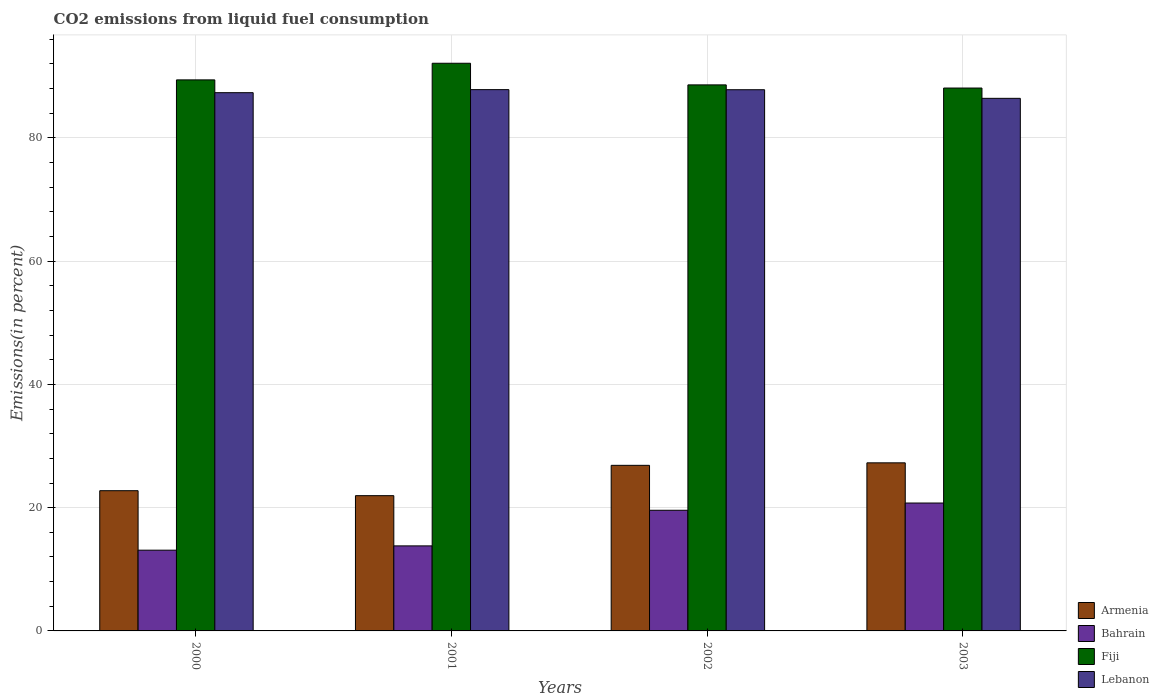How many different coloured bars are there?
Your answer should be compact. 4. Are the number of bars on each tick of the X-axis equal?
Ensure brevity in your answer.  Yes. How many bars are there on the 1st tick from the right?
Offer a very short reply. 4. What is the label of the 4th group of bars from the left?
Provide a short and direct response. 2003. What is the total CO2 emitted in Armenia in 2002?
Your response must be concise. 26.87. Across all years, what is the maximum total CO2 emitted in Fiji?
Your answer should be very brief. 92.11. Across all years, what is the minimum total CO2 emitted in Bahrain?
Offer a terse response. 13.1. What is the total total CO2 emitted in Armenia in the graph?
Offer a terse response. 98.84. What is the difference between the total CO2 emitted in Fiji in 2001 and that in 2003?
Offer a very short reply. 4.02. What is the difference between the total CO2 emitted in Lebanon in 2000 and the total CO2 emitted in Armenia in 2003?
Give a very brief answer. 60.06. What is the average total CO2 emitted in Armenia per year?
Your answer should be very brief. 24.71. In the year 2001, what is the difference between the total CO2 emitted in Bahrain and total CO2 emitted in Lebanon?
Provide a succinct answer. -74.03. What is the ratio of the total CO2 emitted in Bahrain in 2001 to that in 2003?
Your response must be concise. 0.66. Is the total CO2 emitted in Bahrain in 2002 less than that in 2003?
Keep it short and to the point. Yes. What is the difference between the highest and the second highest total CO2 emitted in Armenia?
Give a very brief answer. 0.41. What is the difference between the highest and the lowest total CO2 emitted in Lebanon?
Keep it short and to the point. 1.41. In how many years, is the total CO2 emitted in Armenia greater than the average total CO2 emitted in Armenia taken over all years?
Your answer should be very brief. 2. Is the sum of the total CO2 emitted in Lebanon in 2001 and 2002 greater than the maximum total CO2 emitted in Armenia across all years?
Provide a succinct answer. Yes. Is it the case that in every year, the sum of the total CO2 emitted in Armenia and total CO2 emitted in Lebanon is greater than the sum of total CO2 emitted in Bahrain and total CO2 emitted in Fiji?
Provide a short and direct response. No. What does the 3rd bar from the left in 2002 represents?
Give a very brief answer. Fiji. What does the 3rd bar from the right in 2002 represents?
Provide a short and direct response. Bahrain. How many bars are there?
Keep it short and to the point. 16. Are all the bars in the graph horizontal?
Ensure brevity in your answer.  No. How many years are there in the graph?
Your response must be concise. 4. Are the values on the major ticks of Y-axis written in scientific E-notation?
Your answer should be compact. No. How many legend labels are there?
Give a very brief answer. 4. How are the legend labels stacked?
Ensure brevity in your answer.  Vertical. What is the title of the graph?
Your response must be concise. CO2 emissions from liquid fuel consumption. Does "Malta" appear as one of the legend labels in the graph?
Provide a short and direct response. No. What is the label or title of the X-axis?
Offer a terse response. Years. What is the label or title of the Y-axis?
Provide a short and direct response. Emissions(in percent). What is the Emissions(in percent) in Armenia in 2000?
Keep it short and to the point. 22.75. What is the Emissions(in percent) of Bahrain in 2000?
Keep it short and to the point. 13.1. What is the Emissions(in percent) in Fiji in 2000?
Make the answer very short. 89.41. What is the Emissions(in percent) in Lebanon in 2000?
Your answer should be very brief. 87.33. What is the Emissions(in percent) in Armenia in 2001?
Your response must be concise. 21.95. What is the Emissions(in percent) of Bahrain in 2001?
Provide a succinct answer. 13.8. What is the Emissions(in percent) of Fiji in 2001?
Your answer should be very brief. 92.11. What is the Emissions(in percent) of Lebanon in 2001?
Your answer should be compact. 87.83. What is the Emissions(in percent) in Armenia in 2002?
Provide a short and direct response. 26.87. What is the Emissions(in percent) in Bahrain in 2002?
Your answer should be compact. 19.57. What is the Emissions(in percent) in Fiji in 2002?
Your answer should be compact. 88.6. What is the Emissions(in percent) of Lebanon in 2002?
Offer a terse response. 87.81. What is the Emissions(in percent) of Armenia in 2003?
Your response must be concise. 27.27. What is the Emissions(in percent) of Bahrain in 2003?
Ensure brevity in your answer.  20.75. What is the Emissions(in percent) of Fiji in 2003?
Give a very brief answer. 88.09. What is the Emissions(in percent) of Lebanon in 2003?
Keep it short and to the point. 86.41. Across all years, what is the maximum Emissions(in percent) of Armenia?
Keep it short and to the point. 27.27. Across all years, what is the maximum Emissions(in percent) of Bahrain?
Your response must be concise. 20.75. Across all years, what is the maximum Emissions(in percent) of Fiji?
Your response must be concise. 92.11. Across all years, what is the maximum Emissions(in percent) of Lebanon?
Your answer should be very brief. 87.83. Across all years, what is the minimum Emissions(in percent) of Armenia?
Your response must be concise. 21.95. Across all years, what is the minimum Emissions(in percent) of Bahrain?
Give a very brief answer. 13.1. Across all years, what is the minimum Emissions(in percent) in Fiji?
Make the answer very short. 88.09. Across all years, what is the minimum Emissions(in percent) in Lebanon?
Offer a terse response. 86.41. What is the total Emissions(in percent) of Armenia in the graph?
Your response must be concise. 98.84. What is the total Emissions(in percent) of Bahrain in the graph?
Your response must be concise. 67.22. What is the total Emissions(in percent) of Fiji in the graph?
Offer a very short reply. 358.19. What is the total Emissions(in percent) in Lebanon in the graph?
Your answer should be compact. 349.38. What is the difference between the Emissions(in percent) in Armenia in 2000 and that in 2001?
Your answer should be compact. 0.81. What is the difference between the Emissions(in percent) of Bahrain in 2000 and that in 2001?
Make the answer very short. -0.7. What is the difference between the Emissions(in percent) in Fiji in 2000 and that in 2001?
Give a very brief answer. -2.7. What is the difference between the Emissions(in percent) in Lebanon in 2000 and that in 2001?
Provide a succinct answer. -0.49. What is the difference between the Emissions(in percent) in Armenia in 2000 and that in 2002?
Offer a very short reply. -4.12. What is the difference between the Emissions(in percent) in Bahrain in 2000 and that in 2002?
Keep it short and to the point. -6.47. What is the difference between the Emissions(in percent) in Fiji in 2000 and that in 2002?
Offer a very short reply. 0.81. What is the difference between the Emissions(in percent) of Lebanon in 2000 and that in 2002?
Make the answer very short. -0.48. What is the difference between the Emissions(in percent) of Armenia in 2000 and that in 2003?
Keep it short and to the point. -4.52. What is the difference between the Emissions(in percent) in Bahrain in 2000 and that in 2003?
Give a very brief answer. -7.65. What is the difference between the Emissions(in percent) in Fiji in 2000 and that in 2003?
Your answer should be very brief. 1.32. What is the difference between the Emissions(in percent) of Lebanon in 2000 and that in 2003?
Make the answer very short. 0.92. What is the difference between the Emissions(in percent) of Armenia in 2001 and that in 2002?
Give a very brief answer. -4.92. What is the difference between the Emissions(in percent) of Bahrain in 2001 and that in 2002?
Your answer should be very brief. -5.78. What is the difference between the Emissions(in percent) of Fiji in 2001 and that in 2002?
Keep it short and to the point. 3.51. What is the difference between the Emissions(in percent) in Lebanon in 2001 and that in 2002?
Give a very brief answer. 0.01. What is the difference between the Emissions(in percent) of Armenia in 2001 and that in 2003?
Provide a short and direct response. -5.33. What is the difference between the Emissions(in percent) in Bahrain in 2001 and that in 2003?
Make the answer very short. -6.96. What is the difference between the Emissions(in percent) in Fiji in 2001 and that in 2003?
Your answer should be compact. 4.02. What is the difference between the Emissions(in percent) of Lebanon in 2001 and that in 2003?
Offer a terse response. 1.41. What is the difference between the Emissions(in percent) of Armenia in 2002 and that in 2003?
Keep it short and to the point. -0.41. What is the difference between the Emissions(in percent) in Bahrain in 2002 and that in 2003?
Ensure brevity in your answer.  -1.18. What is the difference between the Emissions(in percent) of Fiji in 2002 and that in 2003?
Ensure brevity in your answer.  0.51. What is the difference between the Emissions(in percent) of Lebanon in 2002 and that in 2003?
Make the answer very short. 1.4. What is the difference between the Emissions(in percent) of Armenia in 2000 and the Emissions(in percent) of Bahrain in 2001?
Ensure brevity in your answer.  8.95. What is the difference between the Emissions(in percent) in Armenia in 2000 and the Emissions(in percent) in Fiji in 2001?
Keep it short and to the point. -69.35. What is the difference between the Emissions(in percent) of Armenia in 2000 and the Emissions(in percent) of Lebanon in 2001?
Provide a succinct answer. -65.07. What is the difference between the Emissions(in percent) in Bahrain in 2000 and the Emissions(in percent) in Fiji in 2001?
Provide a succinct answer. -79.01. What is the difference between the Emissions(in percent) of Bahrain in 2000 and the Emissions(in percent) of Lebanon in 2001?
Give a very brief answer. -74.73. What is the difference between the Emissions(in percent) in Fiji in 2000 and the Emissions(in percent) in Lebanon in 2001?
Your response must be concise. 1.58. What is the difference between the Emissions(in percent) of Armenia in 2000 and the Emissions(in percent) of Bahrain in 2002?
Provide a succinct answer. 3.18. What is the difference between the Emissions(in percent) of Armenia in 2000 and the Emissions(in percent) of Fiji in 2002?
Ensure brevity in your answer.  -65.85. What is the difference between the Emissions(in percent) in Armenia in 2000 and the Emissions(in percent) in Lebanon in 2002?
Your response must be concise. -65.06. What is the difference between the Emissions(in percent) of Bahrain in 2000 and the Emissions(in percent) of Fiji in 2002?
Ensure brevity in your answer.  -75.5. What is the difference between the Emissions(in percent) of Bahrain in 2000 and the Emissions(in percent) of Lebanon in 2002?
Give a very brief answer. -74.71. What is the difference between the Emissions(in percent) in Fiji in 2000 and the Emissions(in percent) in Lebanon in 2002?
Make the answer very short. 1.6. What is the difference between the Emissions(in percent) in Armenia in 2000 and the Emissions(in percent) in Bahrain in 2003?
Ensure brevity in your answer.  2. What is the difference between the Emissions(in percent) of Armenia in 2000 and the Emissions(in percent) of Fiji in 2003?
Your answer should be very brief. -65.33. What is the difference between the Emissions(in percent) of Armenia in 2000 and the Emissions(in percent) of Lebanon in 2003?
Provide a short and direct response. -63.66. What is the difference between the Emissions(in percent) in Bahrain in 2000 and the Emissions(in percent) in Fiji in 2003?
Provide a succinct answer. -74.99. What is the difference between the Emissions(in percent) of Bahrain in 2000 and the Emissions(in percent) of Lebanon in 2003?
Make the answer very short. -73.31. What is the difference between the Emissions(in percent) of Fiji in 2000 and the Emissions(in percent) of Lebanon in 2003?
Make the answer very short. 2.99. What is the difference between the Emissions(in percent) of Armenia in 2001 and the Emissions(in percent) of Bahrain in 2002?
Give a very brief answer. 2.37. What is the difference between the Emissions(in percent) of Armenia in 2001 and the Emissions(in percent) of Fiji in 2002?
Provide a short and direct response. -66.65. What is the difference between the Emissions(in percent) in Armenia in 2001 and the Emissions(in percent) in Lebanon in 2002?
Provide a succinct answer. -65.87. What is the difference between the Emissions(in percent) in Bahrain in 2001 and the Emissions(in percent) in Fiji in 2002?
Offer a terse response. -74.8. What is the difference between the Emissions(in percent) in Bahrain in 2001 and the Emissions(in percent) in Lebanon in 2002?
Give a very brief answer. -74.01. What is the difference between the Emissions(in percent) of Fiji in 2001 and the Emissions(in percent) of Lebanon in 2002?
Your answer should be very brief. 4.29. What is the difference between the Emissions(in percent) in Armenia in 2001 and the Emissions(in percent) in Bahrain in 2003?
Offer a very short reply. 1.19. What is the difference between the Emissions(in percent) of Armenia in 2001 and the Emissions(in percent) of Fiji in 2003?
Your answer should be compact. -66.14. What is the difference between the Emissions(in percent) of Armenia in 2001 and the Emissions(in percent) of Lebanon in 2003?
Provide a succinct answer. -64.47. What is the difference between the Emissions(in percent) in Bahrain in 2001 and the Emissions(in percent) in Fiji in 2003?
Your response must be concise. -74.29. What is the difference between the Emissions(in percent) in Bahrain in 2001 and the Emissions(in percent) in Lebanon in 2003?
Your answer should be very brief. -72.62. What is the difference between the Emissions(in percent) of Fiji in 2001 and the Emissions(in percent) of Lebanon in 2003?
Keep it short and to the point. 5.69. What is the difference between the Emissions(in percent) of Armenia in 2002 and the Emissions(in percent) of Bahrain in 2003?
Keep it short and to the point. 6.11. What is the difference between the Emissions(in percent) of Armenia in 2002 and the Emissions(in percent) of Fiji in 2003?
Your response must be concise. -61.22. What is the difference between the Emissions(in percent) of Armenia in 2002 and the Emissions(in percent) of Lebanon in 2003?
Offer a terse response. -59.55. What is the difference between the Emissions(in percent) in Bahrain in 2002 and the Emissions(in percent) in Fiji in 2003?
Your response must be concise. -68.51. What is the difference between the Emissions(in percent) in Bahrain in 2002 and the Emissions(in percent) in Lebanon in 2003?
Make the answer very short. -66.84. What is the difference between the Emissions(in percent) in Fiji in 2002 and the Emissions(in percent) in Lebanon in 2003?
Provide a short and direct response. 2.18. What is the average Emissions(in percent) in Armenia per year?
Offer a terse response. 24.71. What is the average Emissions(in percent) of Bahrain per year?
Make the answer very short. 16.81. What is the average Emissions(in percent) in Fiji per year?
Offer a very short reply. 89.55. What is the average Emissions(in percent) in Lebanon per year?
Keep it short and to the point. 87.35. In the year 2000, what is the difference between the Emissions(in percent) of Armenia and Emissions(in percent) of Bahrain?
Keep it short and to the point. 9.65. In the year 2000, what is the difference between the Emissions(in percent) of Armenia and Emissions(in percent) of Fiji?
Your answer should be very brief. -66.66. In the year 2000, what is the difference between the Emissions(in percent) in Armenia and Emissions(in percent) in Lebanon?
Offer a very short reply. -64.58. In the year 2000, what is the difference between the Emissions(in percent) in Bahrain and Emissions(in percent) in Fiji?
Keep it short and to the point. -76.31. In the year 2000, what is the difference between the Emissions(in percent) of Bahrain and Emissions(in percent) of Lebanon?
Provide a succinct answer. -74.23. In the year 2000, what is the difference between the Emissions(in percent) in Fiji and Emissions(in percent) in Lebanon?
Give a very brief answer. 2.07. In the year 2001, what is the difference between the Emissions(in percent) of Armenia and Emissions(in percent) of Bahrain?
Your answer should be very brief. 8.15. In the year 2001, what is the difference between the Emissions(in percent) in Armenia and Emissions(in percent) in Fiji?
Provide a succinct answer. -70.16. In the year 2001, what is the difference between the Emissions(in percent) in Armenia and Emissions(in percent) in Lebanon?
Provide a succinct answer. -65.88. In the year 2001, what is the difference between the Emissions(in percent) of Bahrain and Emissions(in percent) of Fiji?
Offer a terse response. -78.31. In the year 2001, what is the difference between the Emissions(in percent) of Bahrain and Emissions(in percent) of Lebanon?
Offer a terse response. -74.03. In the year 2001, what is the difference between the Emissions(in percent) in Fiji and Emissions(in percent) in Lebanon?
Ensure brevity in your answer.  4.28. In the year 2002, what is the difference between the Emissions(in percent) in Armenia and Emissions(in percent) in Bahrain?
Ensure brevity in your answer.  7.29. In the year 2002, what is the difference between the Emissions(in percent) of Armenia and Emissions(in percent) of Fiji?
Your response must be concise. -61.73. In the year 2002, what is the difference between the Emissions(in percent) in Armenia and Emissions(in percent) in Lebanon?
Your response must be concise. -60.94. In the year 2002, what is the difference between the Emissions(in percent) of Bahrain and Emissions(in percent) of Fiji?
Your response must be concise. -69.02. In the year 2002, what is the difference between the Emissions(in percent) in Bahrain and Emissions(in percent) in Lebanon?
Your answer should be very brief. -68.24. In the year 2002, what is the difference between the Emissions(in percent) in Fiji and Emissions(in percent) in Lebanon?
Offer a very short reply. 0.78. In the year 2003, what is the difference between the Emissions(in percent) in Armenia and Emissions(in percent) in Bahrain?
Make the answer very short. 6.52. In the year 2003, what is the difference between the Emissions(in percent) in Armenia and Emissions(in percent) in Fiji?
Offer a terse response. -60.81. In the year 2003, what is the difference between the Emissions(in percent) of Armenia and Emissions(in percent) of Lebanon?
Your answer should be very brief. -59.14. In the year 2003, what is the difference between the Emissions(in percent) of Bahrain and Emissions(in percent) of Fiji?
Provide a short and direct response. -67.33. In the year 2003, what is the difference between the Emissions(in percent) of Bahrain and Emissions(in percent) of Lebanon?
Your response must be concise. -65.66. In the year 2003, what is the difference between the Emissions(in percent) in Fiji and Emissions(in percent) in Lebanon?
Give a very brief answer. 1.67. What is the ratio of the Emissions(in percent) in Armenia in 2000 to that in 2001?
Offer a terse response. 1.04. What is the ratio of the Emissions(in percent) in Bahrain in 2000 to that in 2001?
Your answer should be compact. 0.95. What is the ratio of the Emissions(in percent) of Fiji in 2000 to that in 2001?
Provide a short and direct response. 0.97. What is the ratio of the Emissions(in percent) of Lebanon in 2000 to that in 2001?
Provide a short and direct response. 0.99. What is the ratio of the Emissions(in percent) in Armenia in 2000 to that in 2002?
Your answer should be very brief. 0.85. What is the ratio of the Emissions(in percent) of Bahrain in 2000 to that in 2002?
Provide a short and direct response. 0.67. What is the ratio of the Emissions(in percent) of Fiji in 2000 to that in 2002?
Give a very brief answer. 1.01. What is the ratio of the Emissions(in percent) in Lebanon in 2000 to that in 2002?
Provide a short and direct response. 0.99. What is the ratio of the Emissions(in percent) in Armenia in 2000 to that in 2003?
Ensure brevity in your answer.  0.83. What is the ratio of the Emissions(in percent) of Bahrain in 2000 to that in 2003?
Provide a short and direct response. 0.63. What is the ratio of the Emissions(in percent) of Lebanon in 2000 to that in 2003?
Make the answer very short. 1.01. What is the ratio of the Emissions(in percent) of Armenia in 2001 to that in 2002?
Make the answer very short. 0.82. What is the ratio of the Emissions(in percent) in Bahrain in 2001 to that in 2002?
Your response must be concise. 0.7. What is the ratio of the Emissions(in percent) in Fiji in 2001 to that in 2002?
Give a very brief answer. 1.04. What is the ratio of the Emissions(in percent) of Lebanon in 2001 to that in 2002?
Make the answer very short. 1. What is the ratio of the Emissions(in percent) in Armenia in 2001 to that in 2003?
Make the answer very short. 0.8. What is the ratio of the Emissions(in percent) of Bahrain in 2001 to that in 2003?
Provide a short and direct response. 0.66. What is the ratio of the Emissions(in percent) in Fiji in 2001 to that in 2003?
Make the answer very short. 1.05. What is the ratio of the Emissions(in percent) in Lebanon in 2001 to that in 2003?
Keep it short and to the point. 1.02. What is the ratio of the Emissions(in percent) of Armenia in 2002 to that in 2003?
Offer a very short reply. 0.99. What is the ratio of the Emissions(in percent) in Bahrain in 2002 to that in 2003?
Keep it short and to the point. 0.94. What is the ratio of the Emissions(in percent) in Fiji in 2002 to that in 2003?
Your answer should be very brief. 1.01. What is the ratio of the Emissions(in percent) of Lebanon in 2002 to that in 2003?
Provide a short and direct response. 1.02. What is the difference between the highest and the second highest Emissions(in percent) in Armenia?
Make the answer very short. 0.41. What is the difference between the highest and the second highest Emissions(in percent) of Bahrain?
Give a very brief answer. 1.18. What is the difference between the highest and the second highest Emissions(in percent) of Fiji?
Your answer should be very brief. 2.7. What is the difference between the highest and the second highest Emissions(in percent) of Lebanon?
Offer a terse response. 0.01. What is the difference between the highest and the lowest Emissions(in percent) in Armenia?
Ensure brevity in your answer.  5.33. What is the difference between the highest and the lowest Emissions(in percent) of Bahrain?
Offer a very short reply. 7.65. What is the difference between the highest and the lowest Emissions(in percent) in Fiji?
Your answer should be compact. 4.02. What is the difference between the highest and the lowest Emissions(in percent) of Lebanon?
Ensure brevity in your answer.  1.41. 